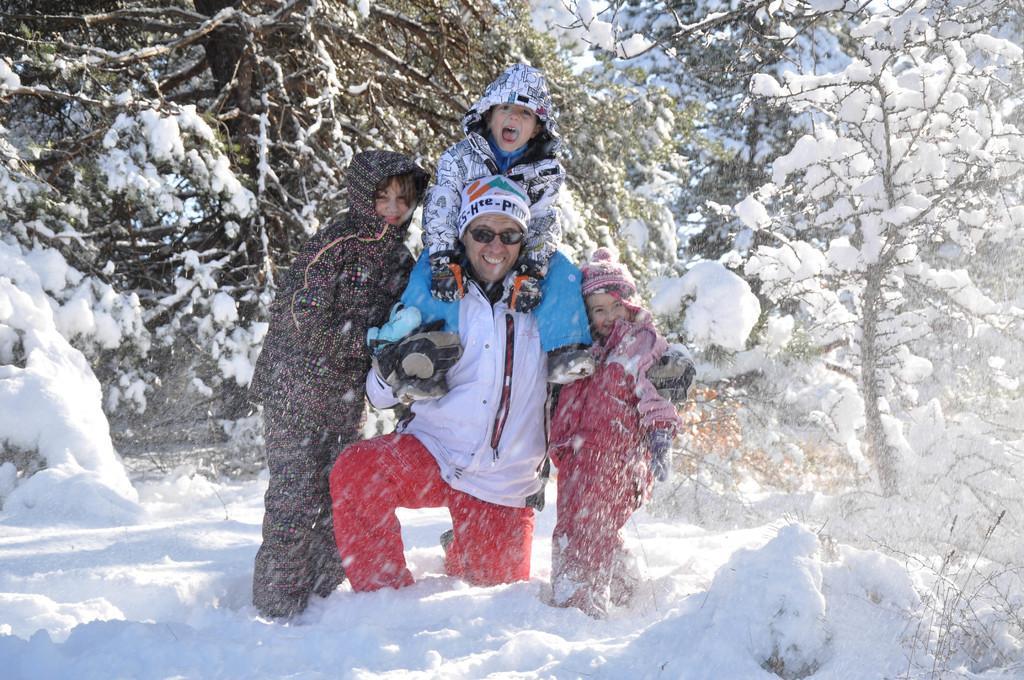Can you describe this image briefly? In this image, I can see four persons smiling. In the background, I can see trees covered with snow. 